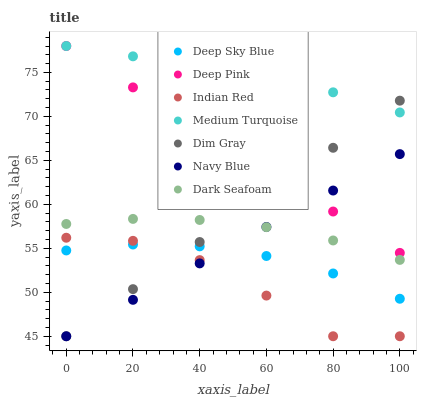Does Indian Red have the minimum area under the curve?
Answer yes or no. Yes. Does Medium Turquoise have the maximum area under the curve?
Answer yes or no. Yes. Does Navy Blue have the minimum area under the curve?
Answer yes or no. No. Does Navy Blue have the maximum area under the curve?
Answer yes or no. No. Is Navy Blue the smoothest?
Answer yes or no. Yes. Is Indian Red the roughest?
Answer yes or no. Yes. Is Indian Red the smoothest?
Answer yes or no. No. Is Navy Blue the roughest?
Answer yes or no. No. Does Dim Gray have the lowest value?
Answer yes or no. Yes. Does Dark Seafoam have the lowest value?
Answer yes or no. No. Does Medium Turquoise have the highest value?
Answer yes or no. Yes. Does Indian Red have the highest value?
Answer yes or no. No. Is Indian Red less than Dark Seafoam?
Answer yes or no. Yes. Is Medium Turquoise greater than Dark Seafoam?
Answer yes or no. Yes. Does Dim Gray intersect Indian Red?
Answer yes or no. Yes. Is Dim Gray less than Indian Red?
Answer yes or no. No. Is Dim Gray greater than Indian Red?
Answer yes or no. No. Does Indian Red intersect Dark Seafoam?
Answer yes or no. No. 